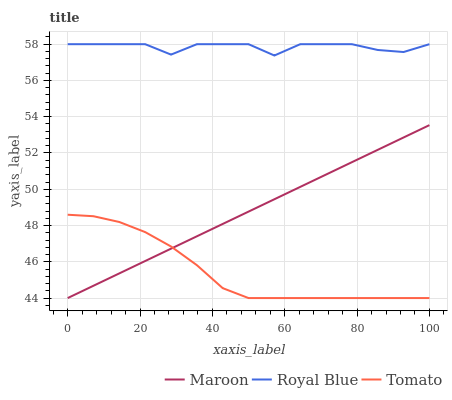Does Maroon have the minimum area under the curve?
Answer yes or no. No. Does Maroon have the maximum area under the curve?
Answer yes or no. No. Is Royal Blue the smoothest?
Answer yes or no. No. Is Maroon the roughest?
Answer yes or no. No. Does Royal Blue have the lowest value?
Answer yes or no. No. Does Maroon have the highest value?
Answer yes or no. No. Is Maroon less than Royal Blue?
Answer yes or no. Yes. Is Royal Blue greater than Maroon?
Answer yes or no. Yes. Does Maroon intersect Royal Blue?
Answer yes or no. No. 